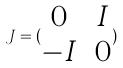Convert formula to latex. <formula><loc_0><loc_0><loc_500><loc_500>J = ( \begin{matrix} 0 & I \\ - I & 0 \end{matrix} )</formula> 